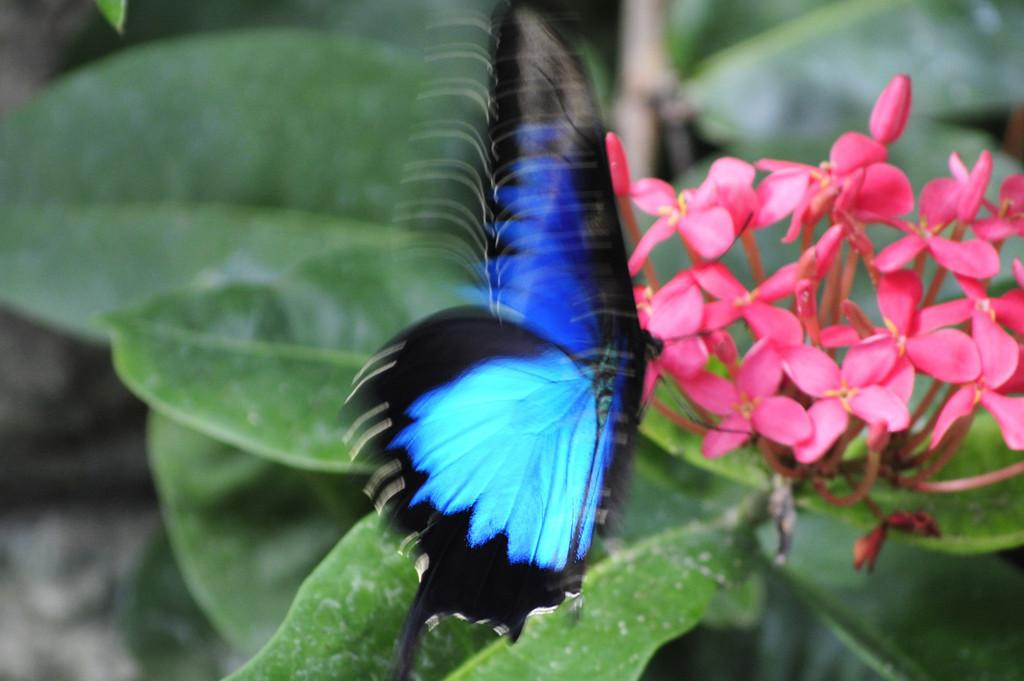What is the main subject in the center of the image? There is a butterfly in the center of the image. What other elements can be seen in the image? There are flowers on a plant in the image. What type of belief does the judge have about the ant in the image? There is no judge or ant present in the image, so it is not possible to answer that question. 